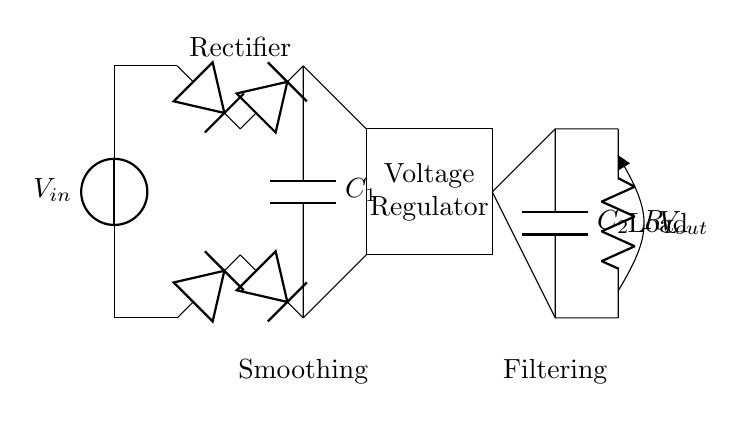What is the function of the smoothing capacitor? The smoothing capacitor, labeled C1, is used to reduce voltage ripple after rectification. It stores charge and releases it when the voltage drops, providing a more constant output voltage.
Answer: Reduce voltage ripple What type of rectifier is used in this circuit? The circuit uses a bridge rectifier, which consists of four diodes arranged in a bridge formation, allowing current to flow during both halves of the AC cycle.
Answer: Bridge rectifier What is the role of the voltage regulator? The voltage regulator maintains a stable output voltage despite variations in input voltage or load current. It achieves this by adjusting the resistance and controlling the output to prevent any significant voltage changes.
Answer: Maintain stable output voltage What is the output voltage labeled as? The output voltage is labeled as Vout in the circuit diagram, indicating the voltage provided to the load after regulation and filtering.
Answer: Vout How many capacitors are in this circuit? There are two capacitors present in the circuit: C1, the smoothing capacitor, and C2, the output capacitor used for additional filtering.
Answer: Two capacitors What is the load resistance in the diagram? The load resistance is labeled as RL, representing the resistance that the output voltage acts upon in the circuit.
Answer: RL 